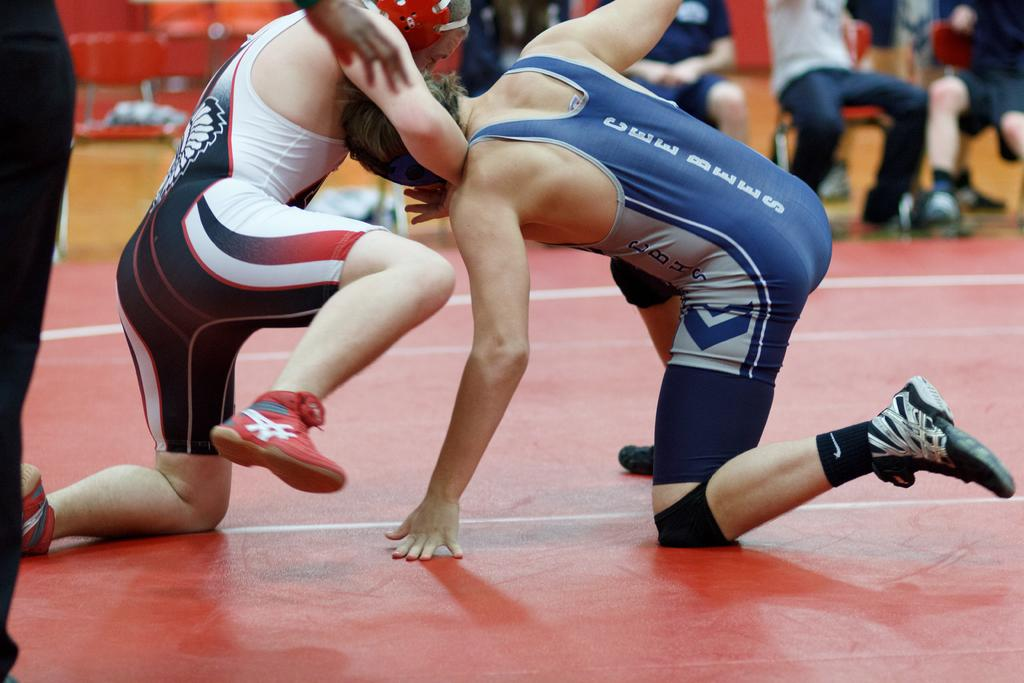Provide a one-sentence caption for the provided image. A wrestler wearing a Cee Bees uniform is competing against a wrestler wearing red, white and blue. 